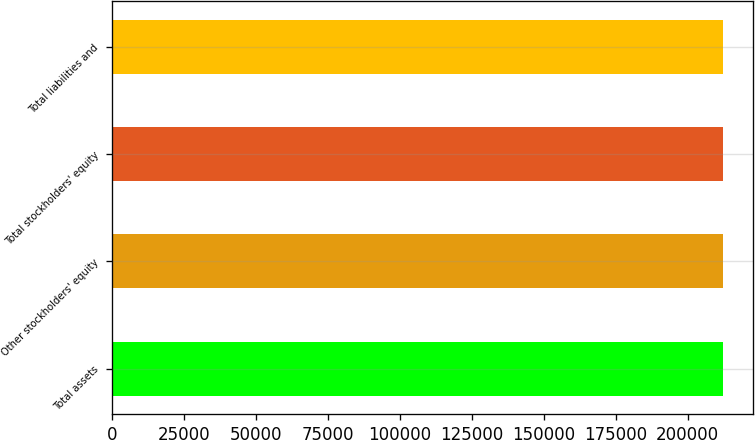Convert chart. <chart><loc_0><loc_0><loc_500><loc_500><bar_chart><fcel>Total assets<fcel>Other stockholders' equity<fcel>Total stockholders' equity<fcel>Total liabilities and<nl><fcel>212318<fcel>212318<fcel>212318<fcel>212318<nl></chart> 